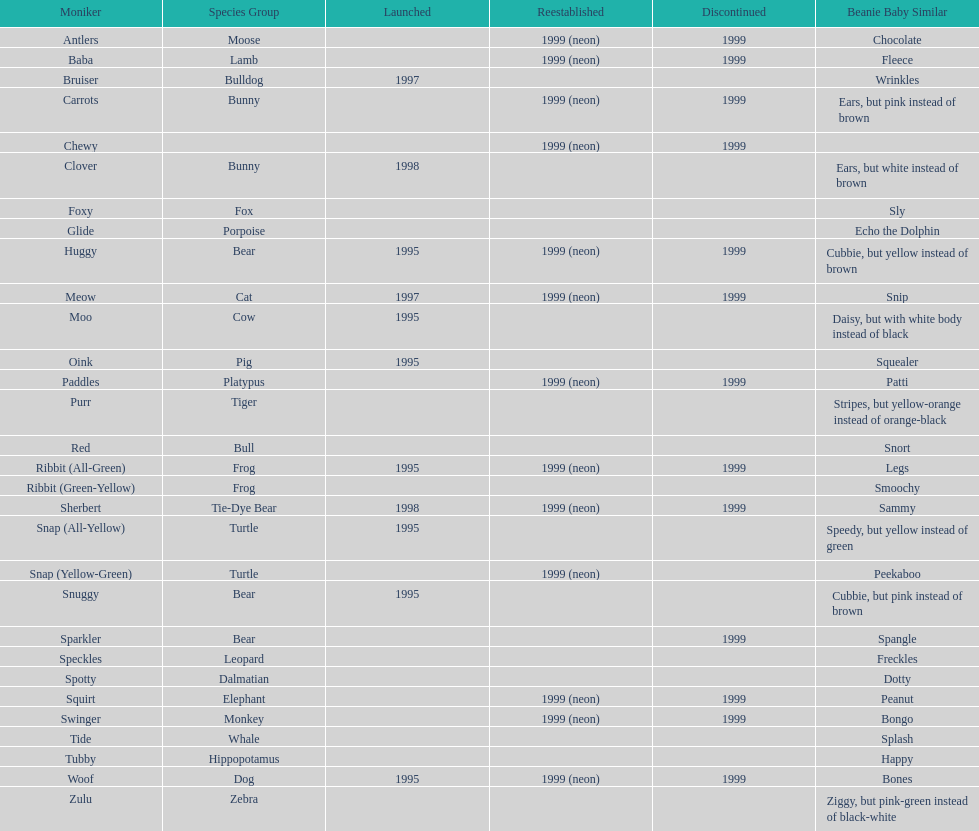What are the total number of pillow pals on this chart? 30. 